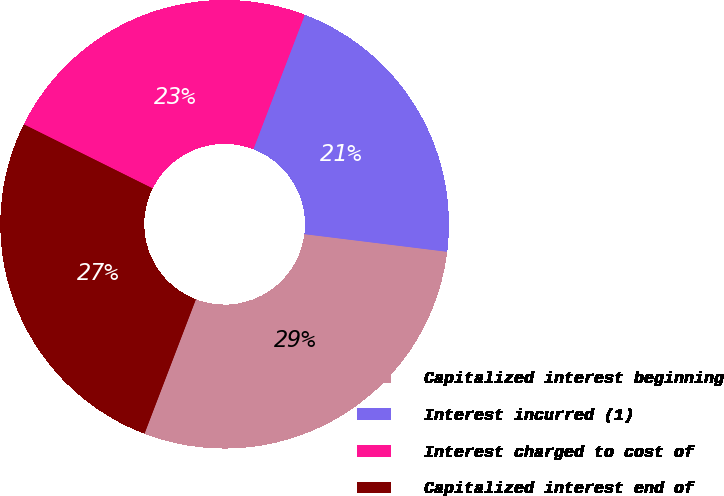Convert chart to OTSL. <chart><loc_0><loc_0><loc_500><loc_500><pie_chart><fcel>Capitalized interest beginning<fcel>Interest incurred (1)<fcel>Interest charged to cost of<fcel>Capitalized interest end of<nl><fcel>28.86%<fcel>21.14%<fcel>23.47%<fcel>26.53%<nl></chart> 